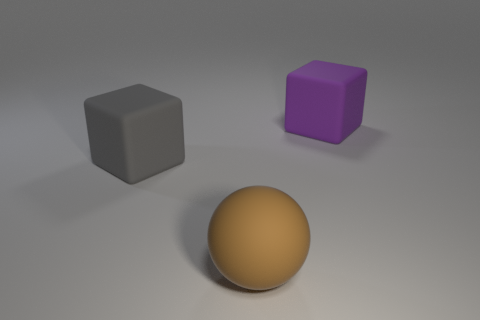Add 1 tiny metallic cylinders. How many objects exist? 4 Subtract all balls. How many objects are left? 2 Add 1 cubes. How many cubes exist? 3 Subtract 0 green blocks. How many objects are left? 3 Subtract all purple rubber things. Subtract all small red rubber things. How many objects are left? 2 Add 3 purple matte cubes. How many purple matte cubes are left? 4 